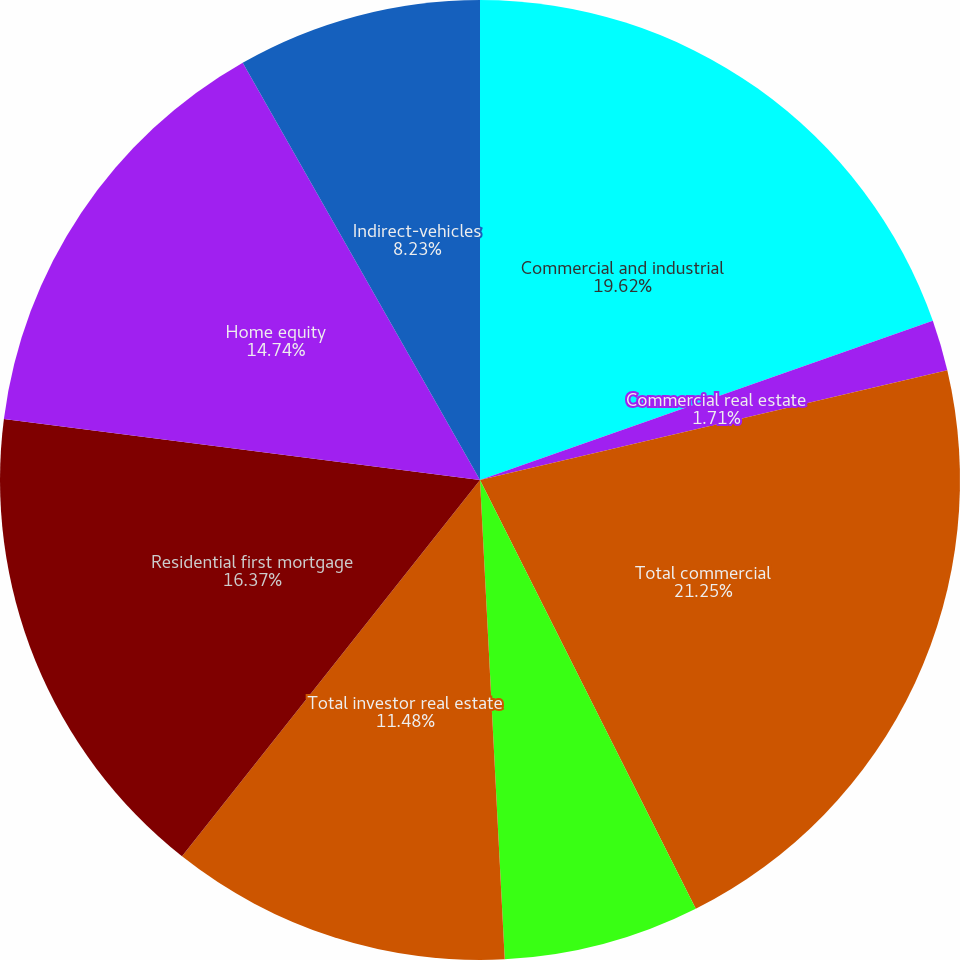Convert chart to OTSL. <chart><loc_0><loc_0><loc_500><loc_500><pie_chart><fcel>Commercial and industrial<fcel>Commercial real estate<fcel>Total commercial<fcel>Commercial investor real<fcel>Total investor real estate<fcel>Residential first mortgage<fcel>Home equity<fcel>Indirect-vehicles<nl><fcel>19.62%<fcel>1.71%<fcel>21.25%<fcel>6.6%<fcel>11.48%<fcel>16.37%<fcel>14.74%<fcel>8.23%<nl></chart> 